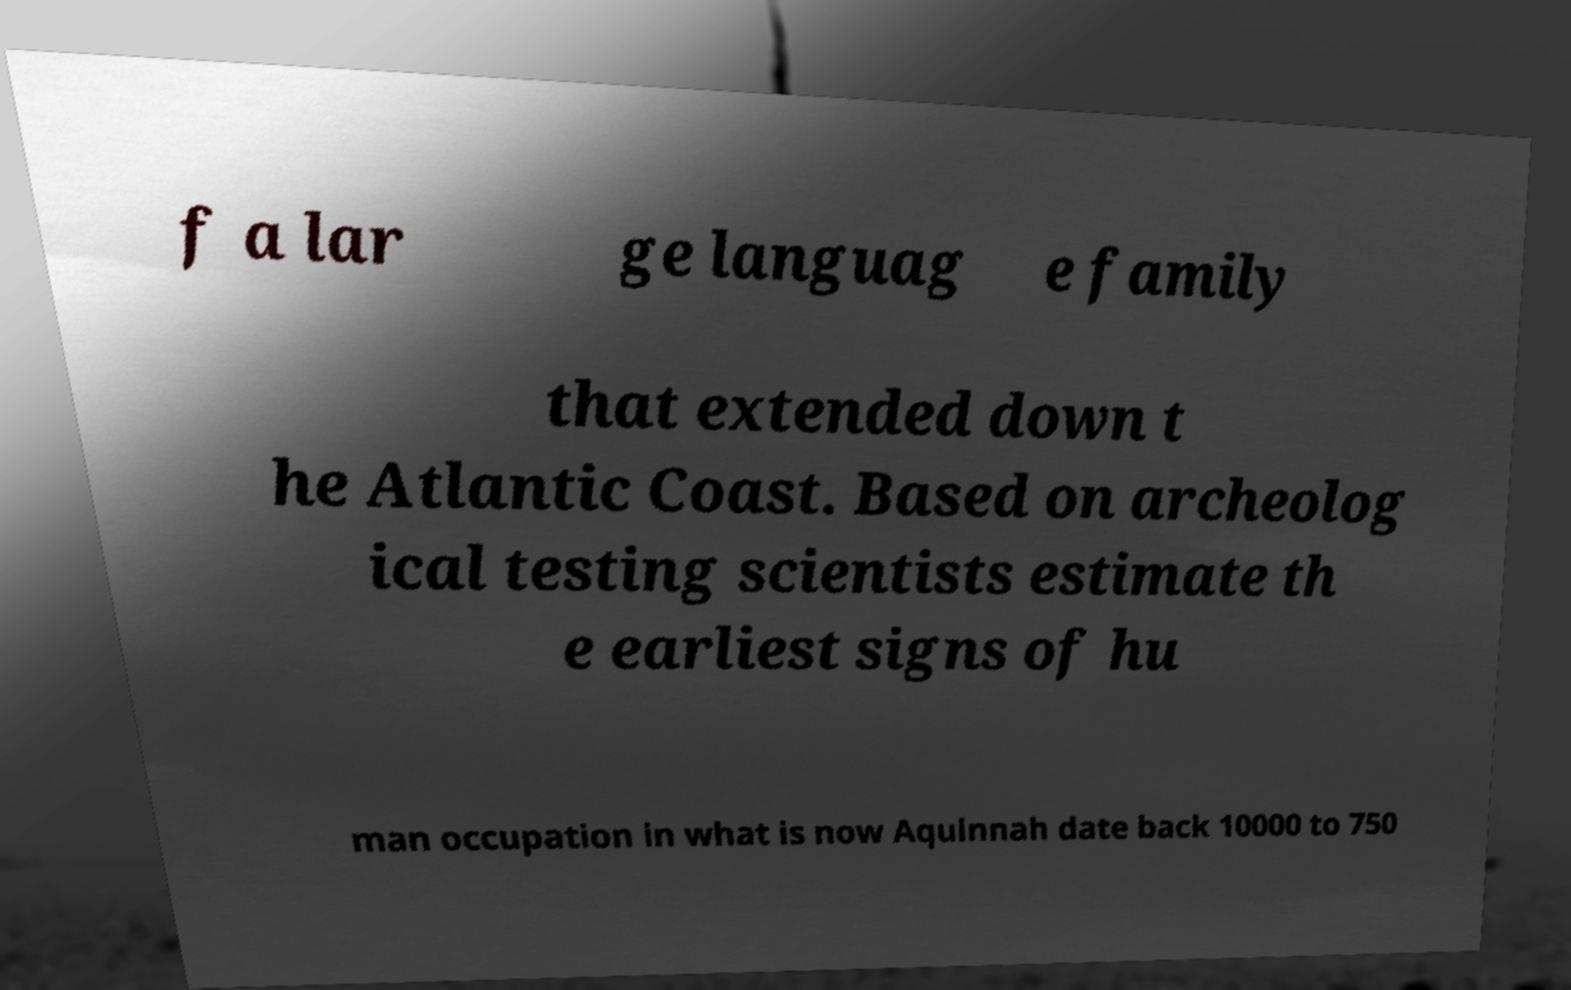Could you extract and type out the text from this image? f a lar ge languag e family that extended down t he Atlantic Coast. Based on archeolog ical testing scientists estimate th e earliest signs of hu man occupation in what is now Aquinnah date back 10000 to 750 